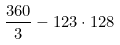<formula> <loc_0><loc_0><loc_500><loc_500>\frac { 3 6 0 } { 3 } - 1 2 3 \cdot 1 2 8</formula> 